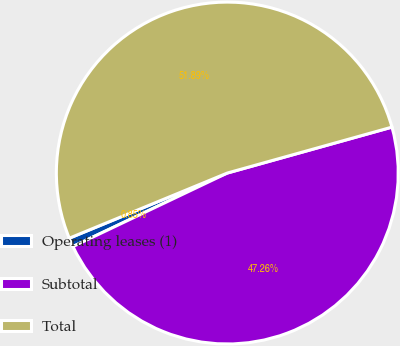Convert chart to OTSL. <chart><loc_0><loc_0><loc_500><loc_500><pie_chart><fcel>Operating leases (1)<fcel>Subtotal<fcel>Total<nl><fcel>0.85%<fcel>47.26%<fcel>51.9%<nl></chart> 